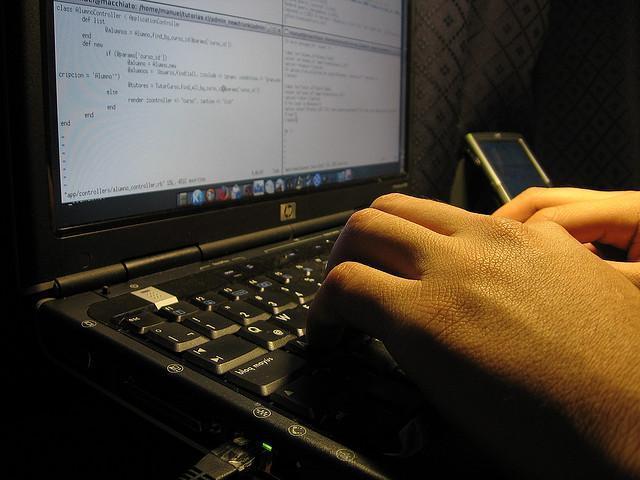How many dogs are depicted?
Give a very brief answer. 0. How many keyboards are there?
Give a very brief answer. 1. How many feet of the elephant are on the ground?
Give a very brief answer. 0. 